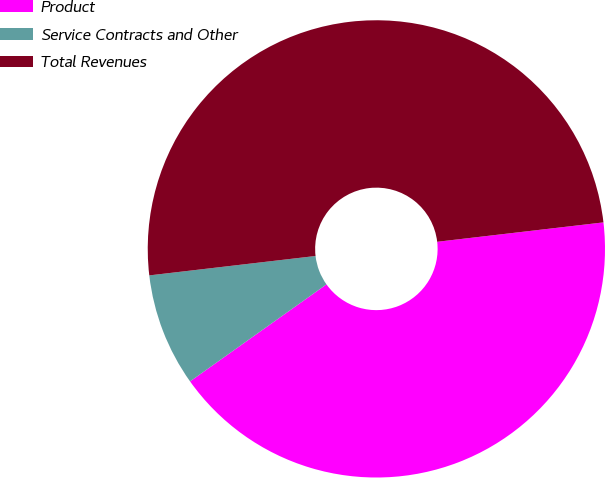Convert chart. <chart><loc_0><loc_0><loc_500><loc_500><pie_chart><fcel>Product<fcel>Service Contracts and Other<fcel>Total Revenues<nl><fcel>42.01%<fcel>7.99%<fcel>50.0%<nl></chart> 